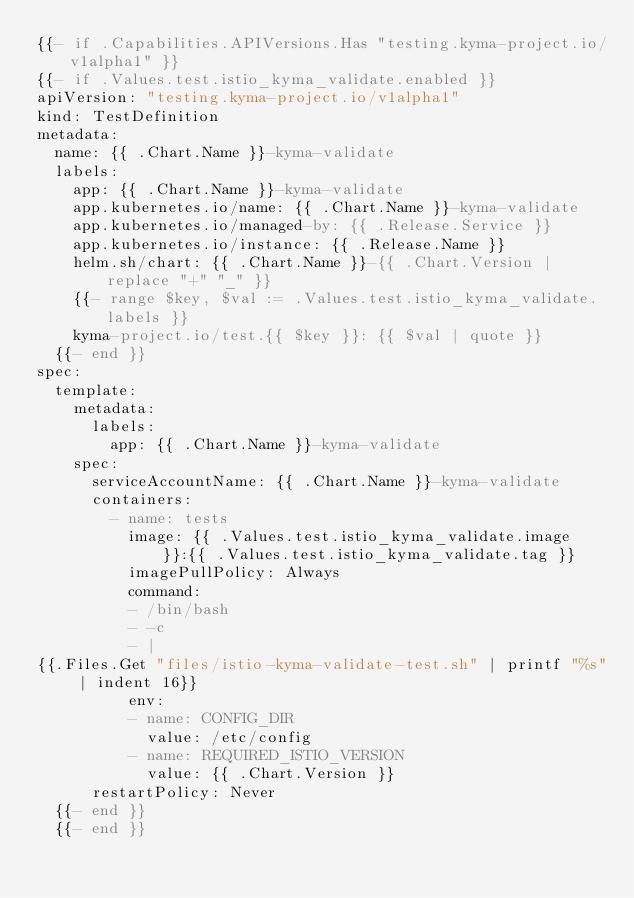<code> <loc_0><loc_0><loc_500><loc_500><_YAML_>{{- if .Capabilities.APIVersions.Has "testing.kyma-project.io/v1alpha1" }}
{{- if .Values.test.istio_kyma_validate.enabled }}
apiVersion: "testing.kyma-project.io/v1alpha1"
kind: TestDefinition
metadata:
  name: {{ .Chart.Name }}-kyma-validate
  labels:
    app: {{ .Chart.Name }}-kyma-validate
    app.kubernetes.io/name: {{ .Chart.Name }}-kyma-validate
    app.kubernetes.io/managed-by: {{ .Release.Service }}
    app.kubernetes.io/instance: {{ .Release.Name }}
    helm.sh/chart: {{ .Chart.Name }}-{{ .Chart.Version | replace "+" "_" }}
    {{- range $key, $val := .Values.test.istio_kyma_validate.labels }}
    kyma-project.io/test.{{ $key }}: {{ $val | quote }}
  {{- end }}
spec:
  template:
    metadata:
      labels:
        app: {{ .Chart.Name }}-kyma-validate
    spec:
      serviceAccountName: {{ .Chart.Name }}-kyma-validate
      containers:
        - name: tests
          image: {{ .Values.test.istio_kyma_validate.image }}:{{ .Values.test.istio_kyma_validate.tag }}
          imagePullPolicy: Always
          command:
          - /bin/bash
          - -c
          - |
{{.Files.Get "files/istio-kyma-validate-test.sh" | printf "%s" | indent 16}}
          env:
          - name: CONFIG_DIR
            value: /etc/config
          - name: REQUIRED_ISTIO_VERSION
            value: {{ .Chart.Version }}
      restartPolicy: Never
  {{- end }}
  {{- end }}
</code> 